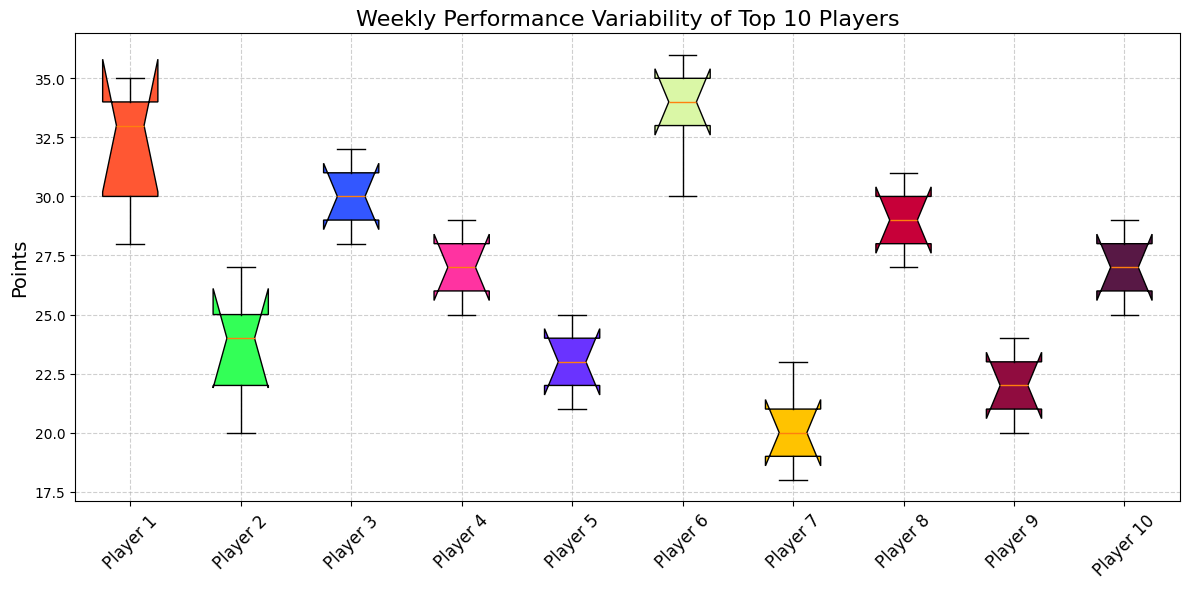Which player has the highest median points? By looking at the notched part of the box plot, which represents the median, we can compare the heights of the medians for each player. The player with the highest median will have the highest notch.
Answer: Player 6 What is the range of points for Player 1? Range is the difference between the maximum and minimum values. In the box plot for Player 1, the top whisker denotes the max and the bottom whisker denotes the min. By finding these values, we subtract the min from the max.
Answer: 35 - 28 = 7 Which player shows the most variability in performance? Variability can be assessed by looking at the interquartile range (IQR), represented by the height of the box. The player with the tallest box exhibits the most variability.
Answer: Player 2 Do any players have outliers in their weekly performances? Outliers are shown as individual points outside the whiskers in a box plot. By checking for these points around any player's whiskers, we can identify if any players have outliers.
Answer: No Which player has more consistent performance: Player 3 or Player 5? Consistency can be judged by the height of the box (IQR) and the length of the whiskers. The shorter the box and whiskers, the more consistent the performance.
Answer: Player 5 What is the median points for Player 4? The median is represented by the notch in the box. By locating and identifying the value of the notch within Player 4's box, we can find the median points.
Answer: 27 Who scored more in the highest week: Player 7 or Player 8? The highest score for a player is shown by the top whisker of each player's box plot. We compare the top whiskers of Player 7 and Player 8.
Answer: Player 8 Which color represents Player 10 in the box plot? By noting the association of colors to players mentioned in the description and locating the matching color in the plot, we identify the color representing Player 10.
Answer: Purple How do Player 6's lowest and Player 9's highest points compare? Compare the lowest point indicated by Player 6's bottom whisker to the highest point indicated by Player 9's top whisker.
Answer: Player 9's highest is lower Which player has the smallest range of points? The range is the difference between the max and min values, represented by the whiskers' endpoints. The player with the smallest distance between these values has the smallest range.
Answer: Player 9 